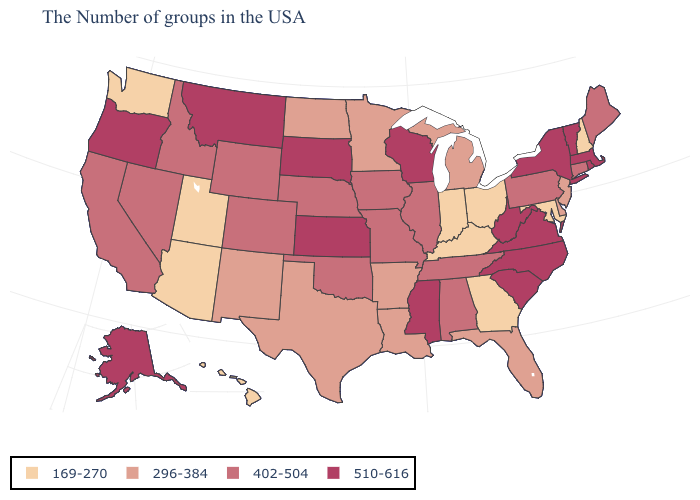What is the value of California?
Write a very short answer. 402-504. Among the states that border Washington , which have the highest value?
Quick response, please. Oregon. Name the states that have a value in the range 510-616?
Concise answer only. Massachusetts, Rhode Island, Vermont, New York, Virginia, North Carolina, South Carolina, West Virginia, Wisconsin, Mississippi, Kansas, South Dakota, Montana, Oregon, Alaska. What is the value of South Dakota?
Quick response, please. 510-616. What is the value of Louisiana?
Write a very short answer. 296-384. What is the value of Illinois?
Quick response, please. 402-504. Does Washington have the lowest value in the USA?
Write a very short answer. Yes. Name the states that have a value in the range 296-384?
Short answer required. New Jersey, Delaware, Florida, Michigan, Louisiana, Arkansas, Minnesota, Texas, North Dakota, New Mexico. What is the value of Iowa?
Keep it brief. 402-504. Name the states that have a value in the range 510-616?
Answer briefly. Massachusetts, Rhode Island, Vermont, New York, Virginia, North Carolina, South Carolina, West Virginia, Wisconsin, Mississippi, Kansas, South Dakota, Montana, Oregon, Alaska. What is the value of New York?
Answer briefly. 510-616. Name the states that have a value in the range 296-384?
Write a very short answer. New Jersey, Delaware, Florida, Michigan, Louisiana, Arkansas, Minnesota, Texas, North Dakota, New Mexico. Does New Jersey have a higher value than Kentucky?
Answer briefly. Yes. Does Colorado have a higher value than Illinois?
Write a very short answer. No. Which states have the highest value in the USA?
Concise answer only. Massachusetts, Rhode Island, Vermont, New York, Virginia, North Carolina, South Carolina, West Virginia, Wisconsin, Mississippi, Kansas, South Dakota, Montana, Oregon, Alaska. 